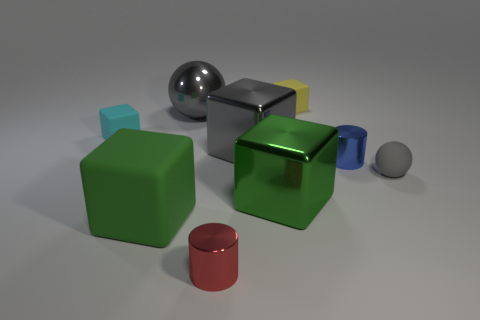Subtract all blue balls. Subtract all gray cylinders. How many balls are left? 2 Subtract all brown blocks. How many brown spheres are left? 0 Add 7 tiny blues. How many big grays exist? 0 Subtract all tiny gray matte balls. Subtract all tiny yellow rubber cubes. How many objects are left? 7 Add 7 small yellow rubber cubes. How many small yellow rubber cubes are left? 8 Add 9 gray metal cylinders. How many gray metal cylinders exist? 9 Add 1 tiny yellow metallic balls. How many objects exist? 10 Subtract all green blocks. How many blocks are left? 3 Subtract all big green blocks. How many blocks are left? 3 Subtract 0 blue blocks. How many objects are left? 9 